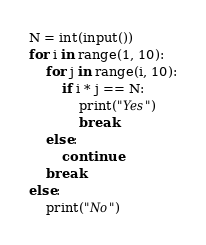Convert code to text. <code><loc_0><loc_0><loc_500><loc_500><_Python_>N = int(input())
for i in range(1, 10):
    for j in range(i, 10):
        if i * j == N:
            print("Yes")
            break
    else:
        continue
    break
else:
    print("No")
</code> 